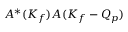Convert formula to latex. <formula><loc_0><loc_0><loc_500><loc_500>A ^ { * } ( K _ { f } ) A ( K _ { f } - Q _ { p } )</formula> 